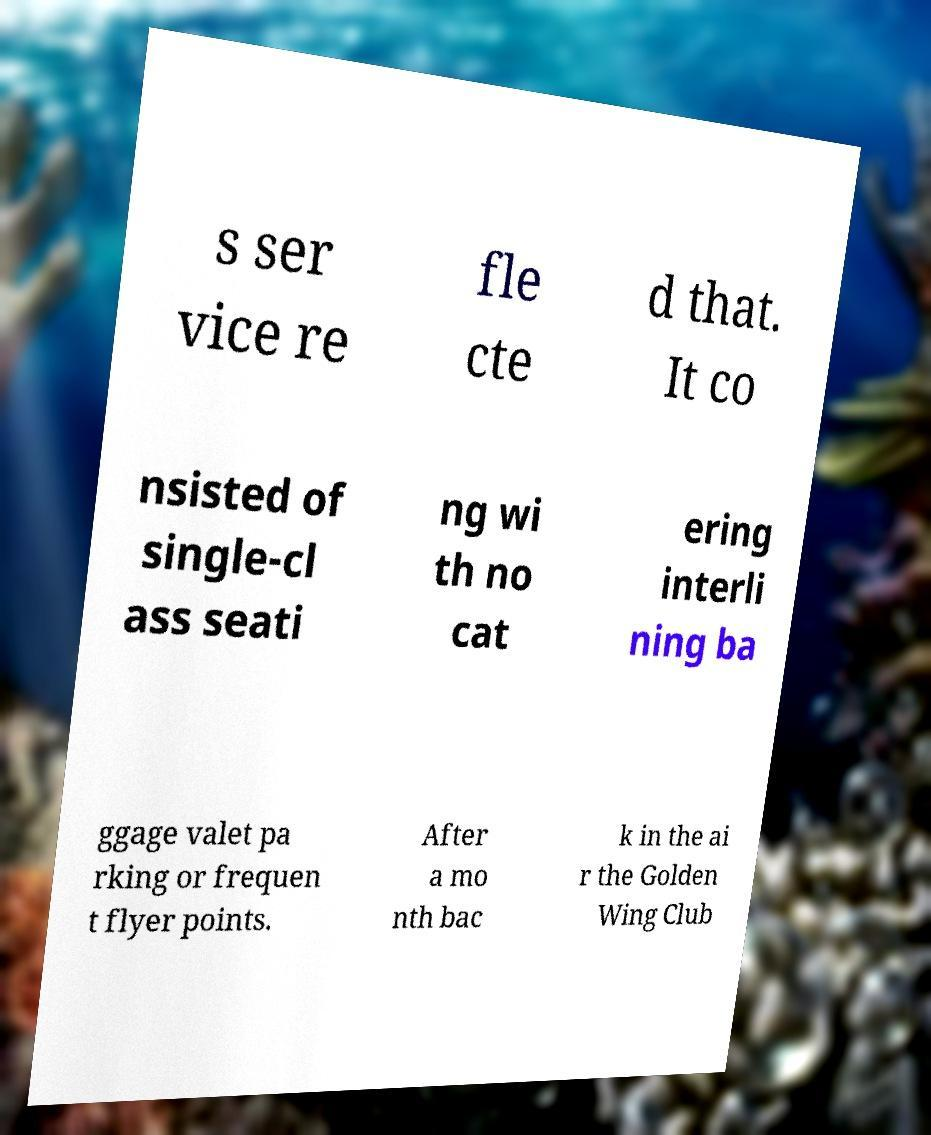What messages or text are displayed in this image? I need them in a readable, typed format. s ser vice re fle cte d that. It co nsisted of single-cl ass seati ng wi th no cat ering interli ning ba ggage valet pa rking or frequen t flyer points. After a mo nth bac k in the ai r the Golden Wing Club 